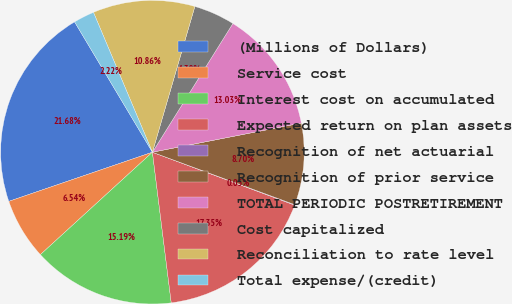Convert chart to OTSL. <chart><loc_0><loc_0><loc_500><loc_500><pie_chart><fcel>(Millions of Dollars)<fcel>Service cost<fcel>Interest cost on accumulated<fcel>Expected return on plan assets<fcel>Recognition of net actuarial<fcel>Recognition of prior service<fcel>TOTAL PERIODIC POSTRETIREMENT<fcel>Cost capitalized<fcel>Reconciliation to rate level<fcel>Total expense/(credit)<nl><fcel>21.68%<fcel>6.54%<fcel>15.19%<fcel>17.35%<fcel>0.05%<fcel>8.7%<fcel>13.03%<fcel>4.38%<fcel>10.86%<fcel>2.22%<nl></chart> 